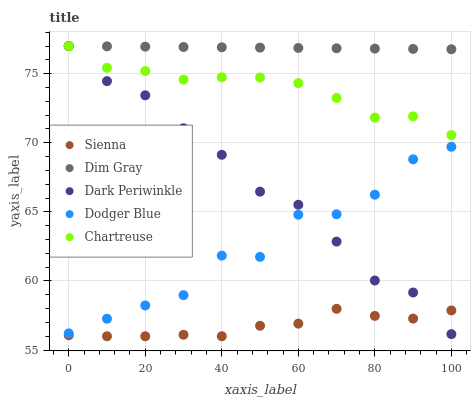Does Sienna have the minimum area under the curve?
Answer yes or no. Yes. Does Dim Gray have the maximum area under the curve?
Answer yes or no. Yes. Does Chartreuse have the minimum area under the curve?
Answer yes or no. No. Does Chartreuse have the maximum area under the curve?
Answer yes or no. No. Is Dim Gray the smoothest?
Answer yes or no. Yes. Is Dodger Blue the roughest?
Answer yes or no. Yes. Is Chartreuse the smoothest?
Answer yes or no. No. Is Chartreuse the roughest?
Answer yes or no. No. Does Sienna have the lowest value?
Answer yes or no. Yes. Does Chartreuse have the lowest value?
Answer yes or no. No. Does Dark Periwinkle have the highest value?
Answer yes or no. Yes. Does Dodger Blue have the highest value?
Answer yes or no. No. Is Sienna less than Dodger Blue?
Answer yes or no. Yes. Is Dodger Blue greater than Sienna?
Answer yes or no. Yes. Does Sienna intersect Dark Periwinkle?
Answer yes or no. Yes. Is Sienna less than Dark Periwinkle?
Answer yes or no. No. Is Sienna greater than Dark Periwinkle?
Answer yes or no. No. Does Sienna intersect Dodger Blue?
Answer yes or no. No. 